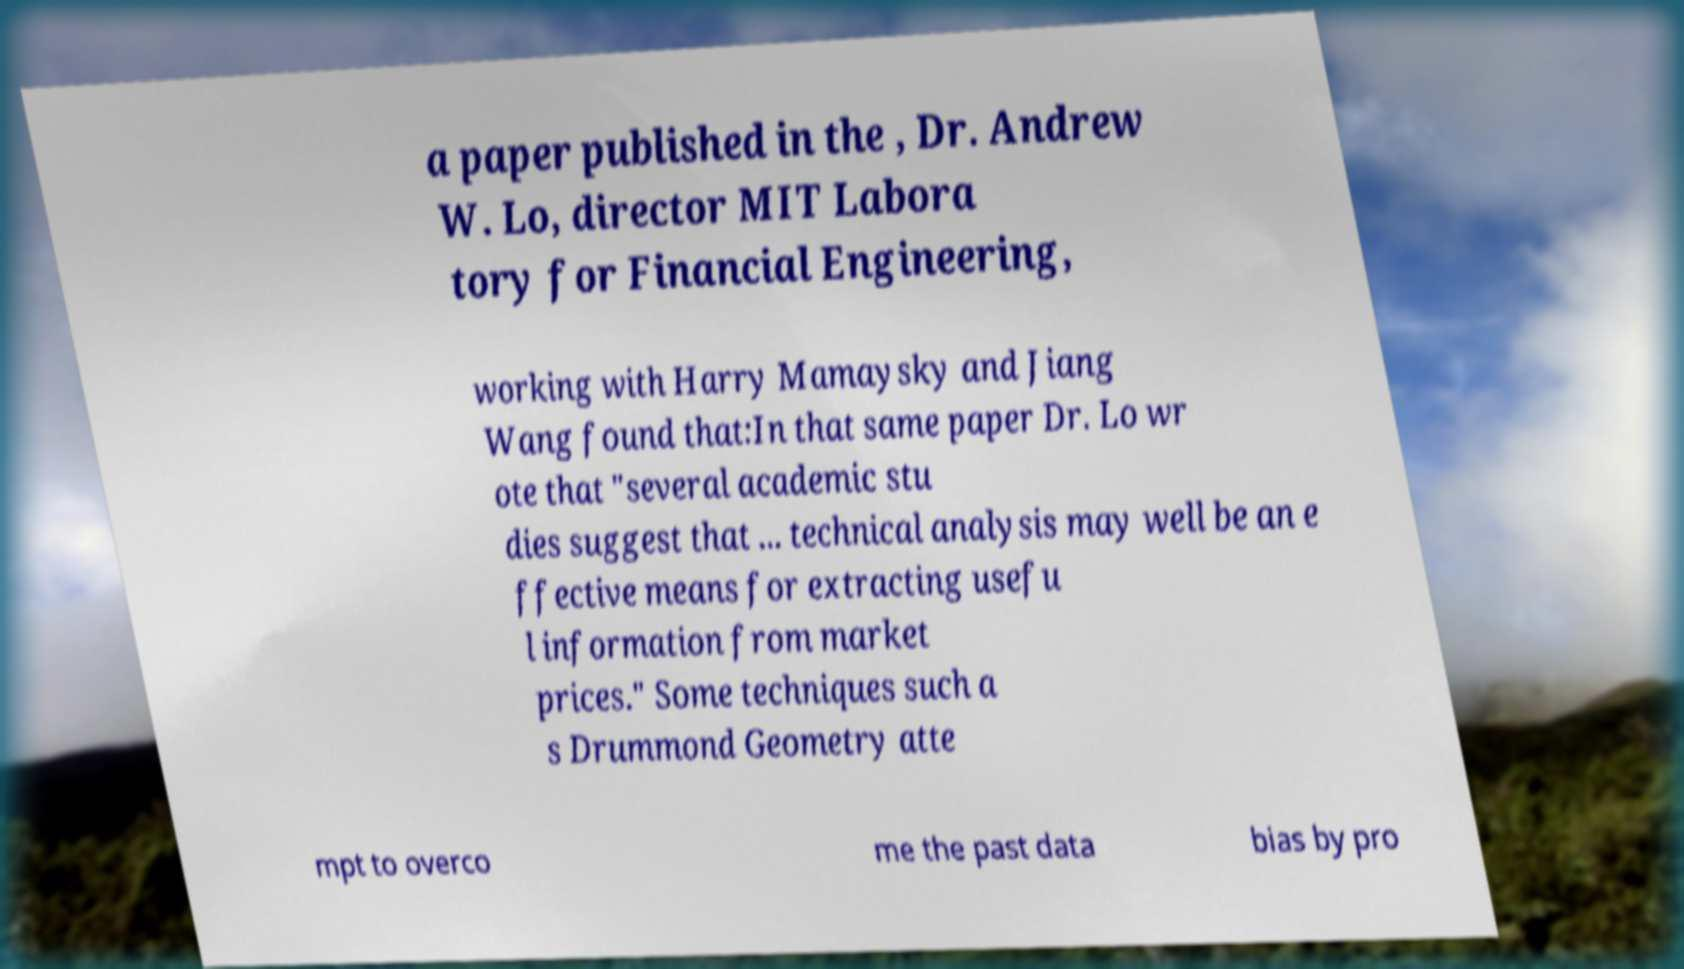I need the written content from this picture converted into text. Can you do that? a paper published in the , Dr. Andrew W. Lo, director MIT Labora tory for Financial Engineering, working with Harry Mamaysky and Jiang Wang found that:In that same paper Dr. Lo wr ote that "several academic stu dies suggest that ... technical analysis may well be an e ffective means for extracting usefu l information from market prices." Some techniques such a s Drummond Geometry atte mpt to overco me the past data bias by pro 